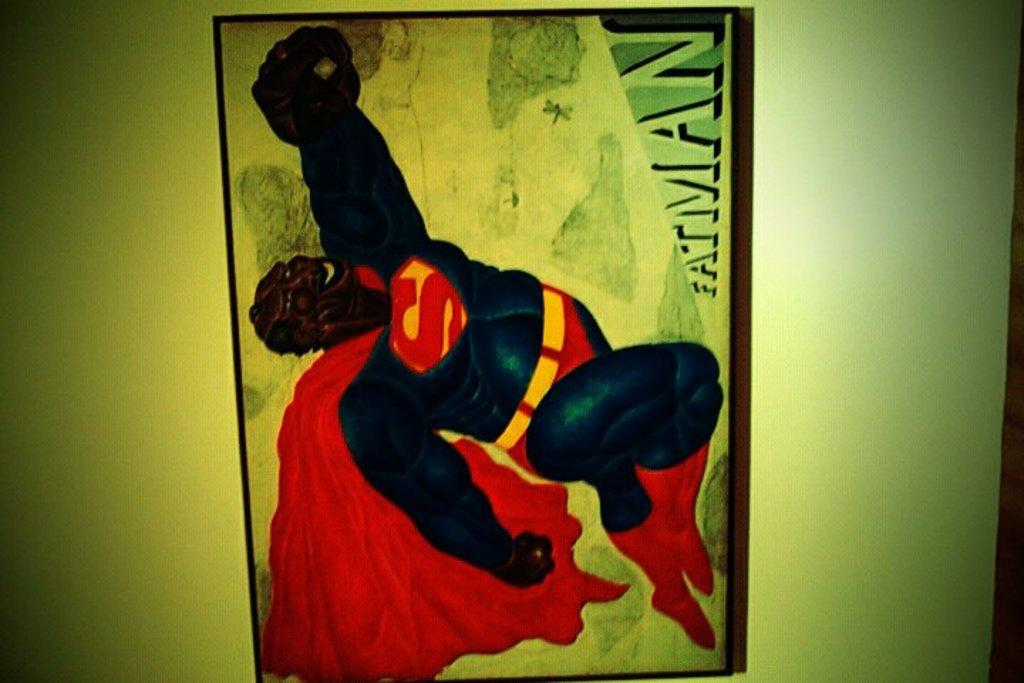<image>
Describe the image concisely. a drawing of superman but with teh label fatman beneath it 